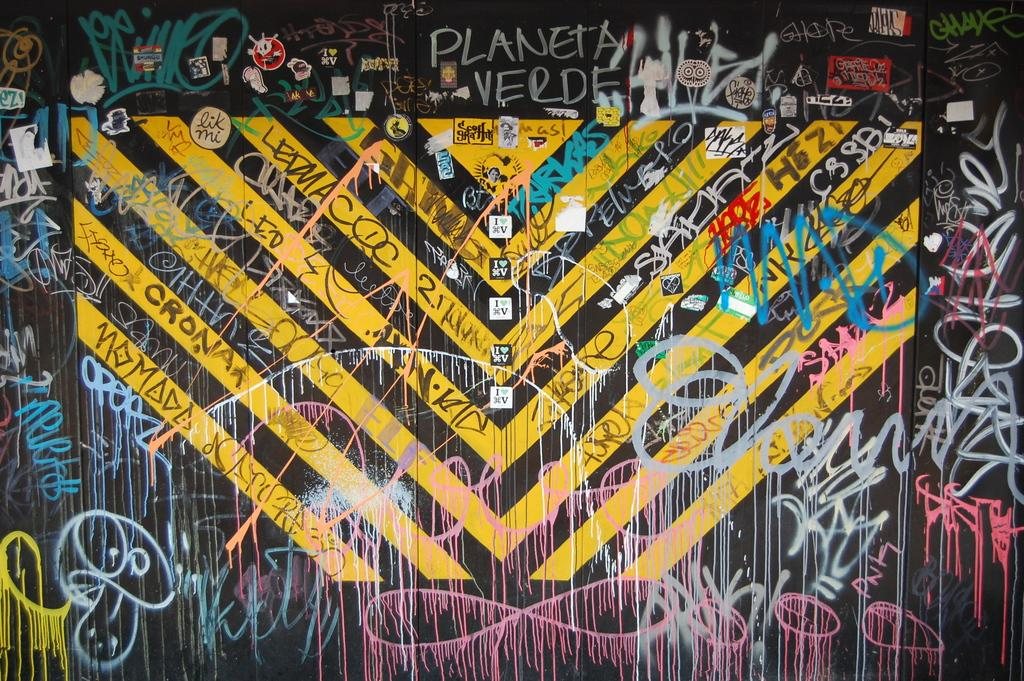<image>
Provide a brief description of the given image. a large amount of graffiti on a wall and the planeta verde is mentioned 